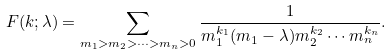<formula> <loc_0><loc_0><loc_500><loc_500>F ( k ; \lambda ) = \sum _ { m _ { 1 } > m _ { 2 } > \dots > m _ { n } > 0 } \frac { 1 } { m _ { 1 } ^ { k _ { 1 } } ( m _ { 1 } - \lambda ) m _ { 2 } ^ { k _ { 2 } } \cdots m _ { n } ^ { k _ { n } } } .</formula> 